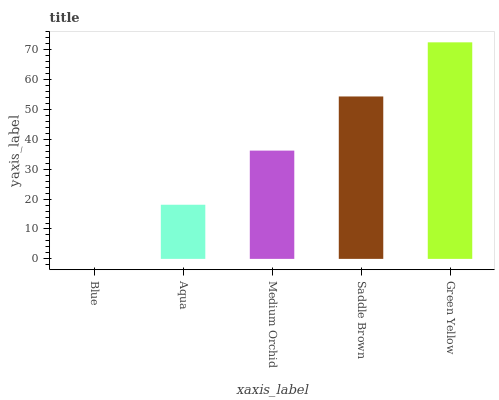Is Blue the minimum?
Answer yes or no. Yes. Is Green Yellow the maximum?
Answer yes or no. Yes. Is Aqua the minimum?
Answer yes or no. No. Is Aqua the maximum?
Answer yes or no. No. Is Aqua greater than Blue?
Answer yes or no. Yes. Is Blue less than Aqua?
Answer yes or no. Yes. Is Blue greater than Aqua?
Answer yes or no. No. Is Aqua less than Blue?
Answer yes or no. No. Is Medium Orchid the high median?
Answer yes or no. Yes. Is Medium Orchid the low median?
Answer yes or no. Yes. Is Saddle Brown the high median?
Answer yes or no. No. Is Saddle Brown the low median?
Answer yes or no. No. 